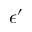Convert formula to latex. <formula><loc_0><loc_0><loc_500><loc_500>\epsilon ^ { \prime }</formula> 